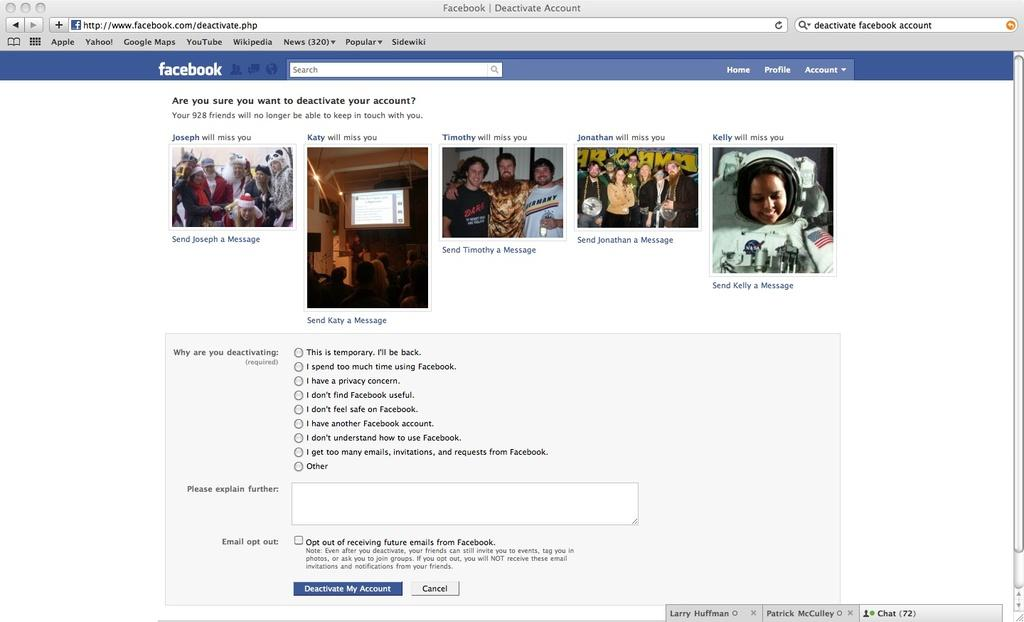What is the main subject of the image? The main subject of the image is a web page. What can be seen on the web page? There are people visible on the web page, along with text and other objects. What type of pollution can be seen on the coast in the image? There is no coast or pollution present in the image, as it features a web page with people, text, and other objects. 